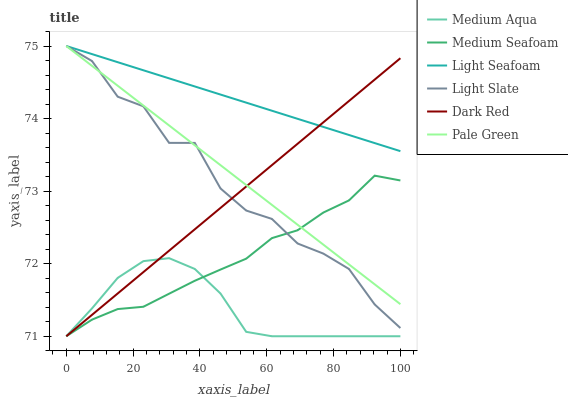Does Medium Aqua have the minimum area under the curve?
Answer yes or no. Yes. Does Light Seafoam have the maximum area under the curve?
Answer yes or no. Yes. Does Dark Red have the minimum area under the curve?
Answer yes or no. No. Does Dark Red have the maximum area under the curve?
Answer yes or no. No. Is Light Seafoam the smoothest?
Answer yes or no. Yes. Is Light Slate the roughest?
Answer yes or no. Yes. Is Dark Red the smoothest?
Answer yes or no. No. Is Dark Red the roughest?
Answer yes or no. No. Does Pale Green have the lowest value?
Answer yes or no. No. Does Dark Red have the highest value?
Answer yes or no. No. Is Medium Aqua less than Pale Green?
Answer yes or no. Yes. Is Light Seafoam greater than Medium Seafoam?
Answer yes or no. Yes. Does Medium Aqua intersect Pale Green?
Answer yes or no. No. 